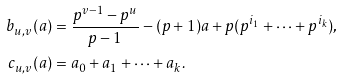Convert formula to latex. <formula><loc_0><loc_0><loc_500><loc_500>b _ { u , v } ( a ) & = \frac { p ^ { v - 1 } - p ^ { u } } { p - 1 } - ( p + 1 ) a + p ( p ^ { i _ { 1 } } + \dots + p ^ { i _ { k } } ) , \\ c _ { u , v } ( a ) & = a _ { 0 } + a _ { 1 } + \dots + a _ { k } .</formula> 